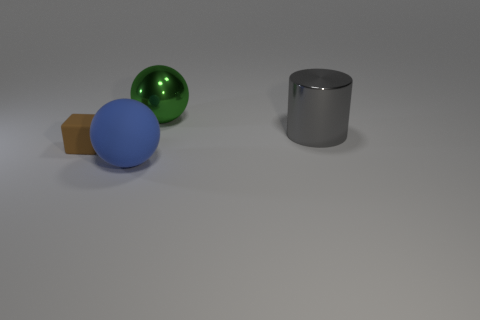Add 3 brown blocks. How many objects exist? 7 Add 2 brown rubber blocks. How many brown rubber blocks are left? 3 Add 3 large gray rubber cylinders. How many large gray rubber cylinders exist? 3 Subtract 0 red cylinders. How many objects are left? 4 Subtract all cubes. How many objects are left? 3 Subtract all gray cubes. Subtract all yellow cylinders. How many cubes are left? 1 Subtract all small brown rubber objects. Subtract all big green objects. How many objects are left? 2 